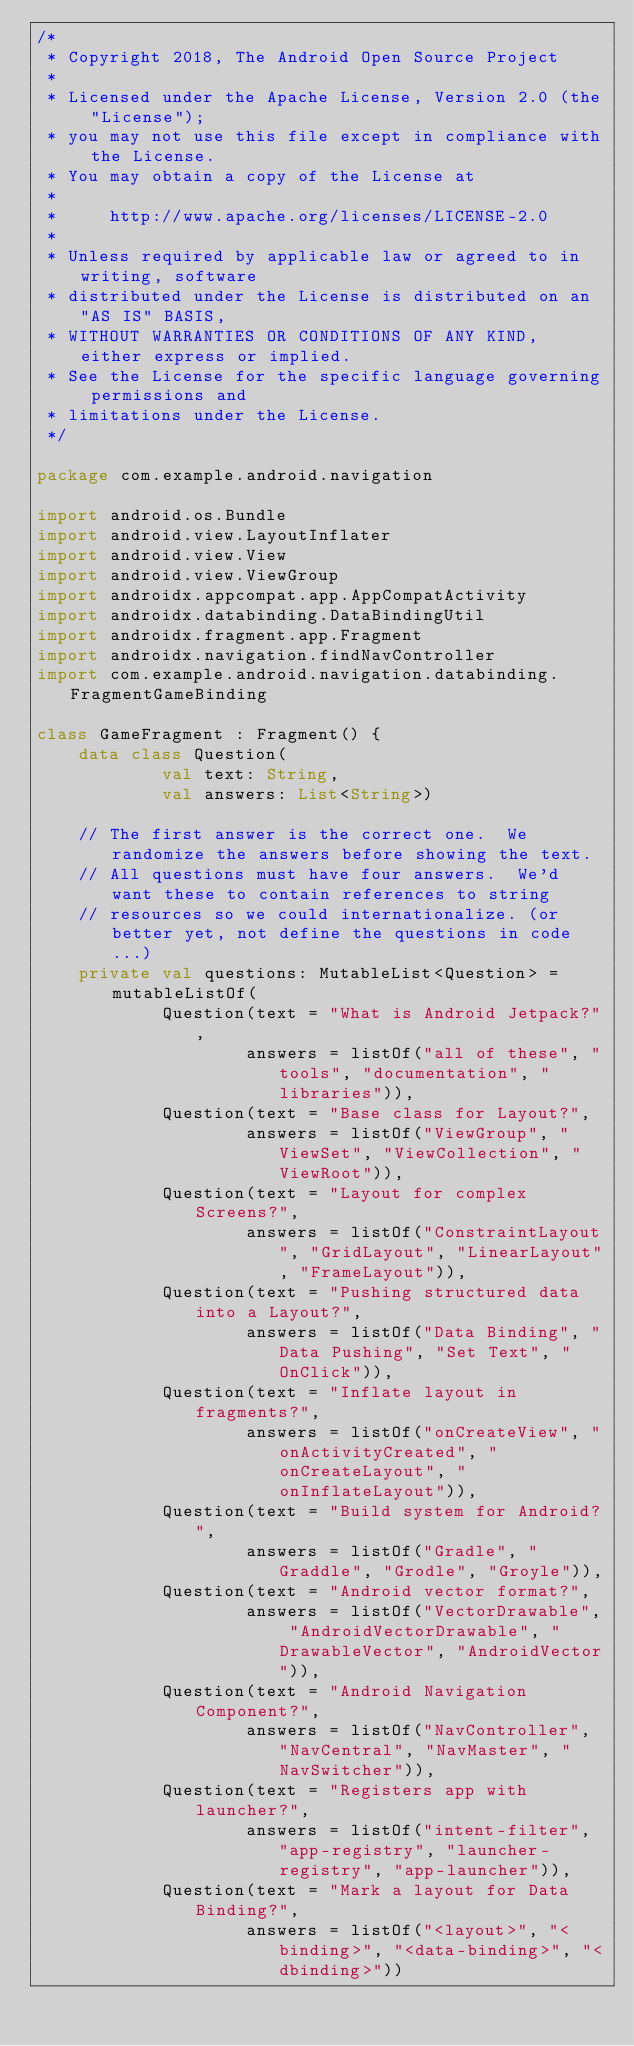<code> <loc_0><loc_0><loc_500><loc_500><_Kotlin_>/*
 * Copyright 2018, The Android Open Source Project
 *
 * Licensed under the Apache License, Version 2.0 (the "License");
 * you may not use this file except in compliance with the License.
 * You may obtain a copy of the License at
 *
 *     http://www.apache.org/licenses/LICENSE-2.0
 *
 * Unless required by applicable law or agreed to in writing, software
 * distributed under the License is distributed on an "AS IS" BASIS,
 * WITHOUT WARRANTIES OR CONDITIONS OF ANY KIND, either express or implied.
 * See the License for the specific language governing permissions and
 * limitations under the License.
 */

package com.example.android.navigation

import android.os.Bundle
import android.view.LayoutInflater
import android.view.View
import android.view.ViewGroup
import androidx.appcompat.app.AppCompatActivity
import androidx.databinding.DataBindingUtil
import androidx.fragment.app.Fragment
import androidx.navigation.findNavController
import com.example.android.navigation.databinding.FragmentGameBinding

class GameFragment : Fragment() {
    data class Question(
            val text: String,
            val answers: List<String>)

    // The first answer is the correct one.  We randomize the answers before showing the text.
    // All questions must have four answers.  We'd want these to contain references to string
    // resources so we could internationalize. (or better yet, not define the questions in code...)
    private val questions: MutableList<Question> = mutableListOf(
            Question(text = "What is Android Jetpack?",
                    answers = listOf("all of these", "tools", "documentation", "libraries")),
            Question(text = "Base class for Layout?",
                    answers = listOf("ViewGroup", "ViewSet", "ViewCollection", "ViewRoot")),
            Question(text = "Layout for complex Screens?",
                    answers = listOf("ConstraintLayout", "GridLayout", "LinearLayout", "FrameLayout")),
            Question(text = "Pushing structured data into a Layout?",
                    answers = listOf("Data Binding", "Data Pushing", "Set Text", "OnClick")),
            Question(text = "Inflate layout in fragments?",
                    answers = listOf("onCreateView", "onActivityCreated", "onCreateLayout", "onInflateLayout")),
            Question(text = "Build system for Android?",
                    answers = listOf("Gradle", "Graddle", "Grodle", "Groyle")),
            Question(text = "Android vector format?",
                    answers = listOf("VectorDrawable", "AndroidVectorDrawable", "DrawableVector", "AndroidVector")),
            Question(text = "Android Navigation Component?",
                    answers = listOf("NavController", "NavCentral", "NavMaster", "NavSwitcher")),
            Question(text = "Registers app with launcher?",
                    answers = listOf("intent-filter", "app-registry", "launcher-registry", "app-launcher")),
            Question(text = "Mark a layout for Data Binding?",
                    answers = listOf("<layout>", "<binding>", "<data-binding>", "<dbinding>"))</code> 